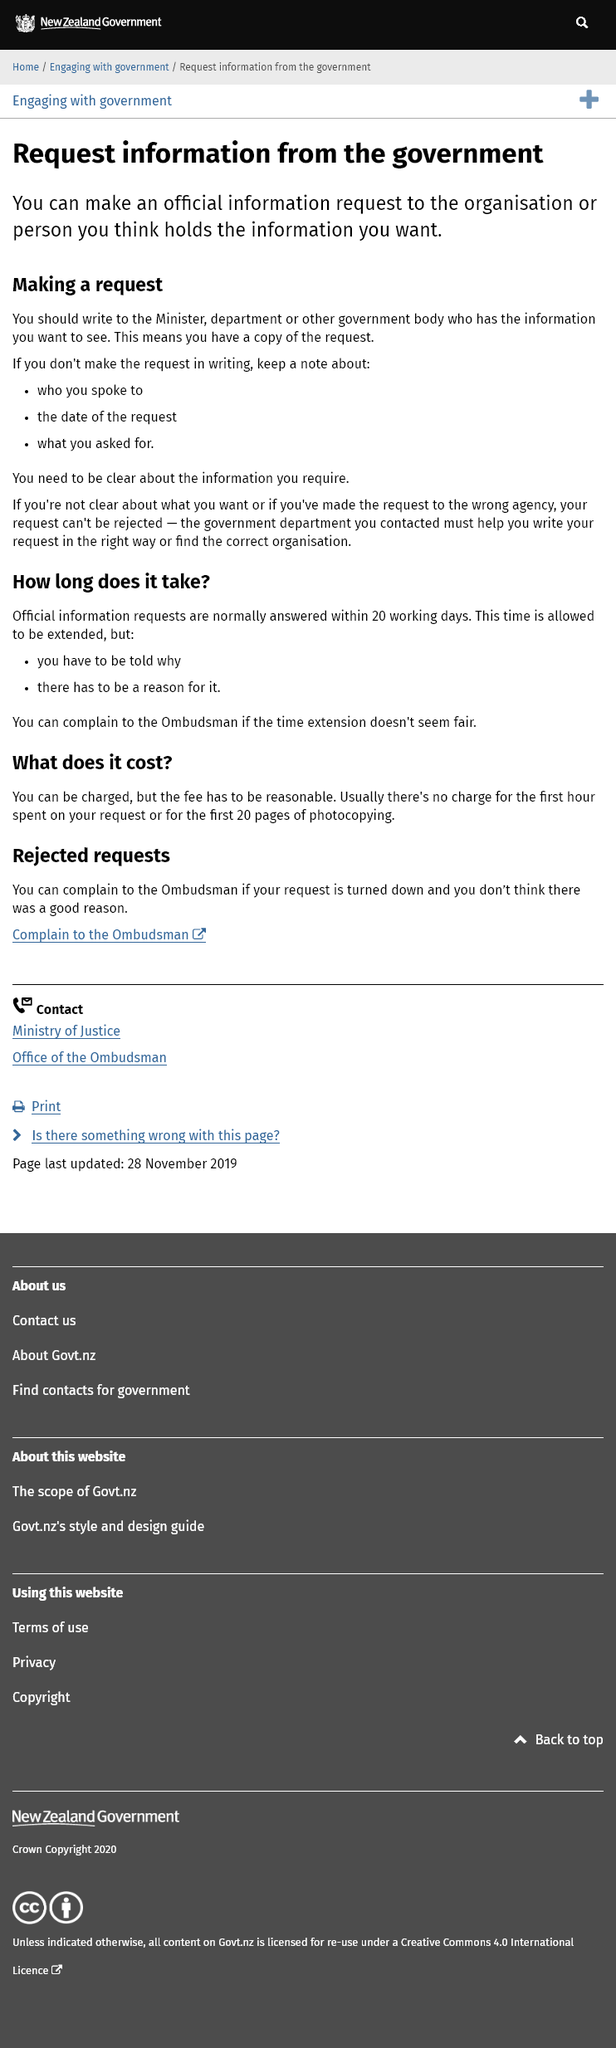Mention a couple of crucial points in this snapshot. It is advisable to make a verbal request for government information while keeping a record of the conversation, including the name of the person spoken to, the date, and the details of the request. If I contact the wrong agency for my request of information, I can seek help from the government department I originally contacted, which will assist me in locating the appropriate organization to fulfill my request. Yes, it is possible to make a written request for government information to the Minister, department, or government body that holds the information. 